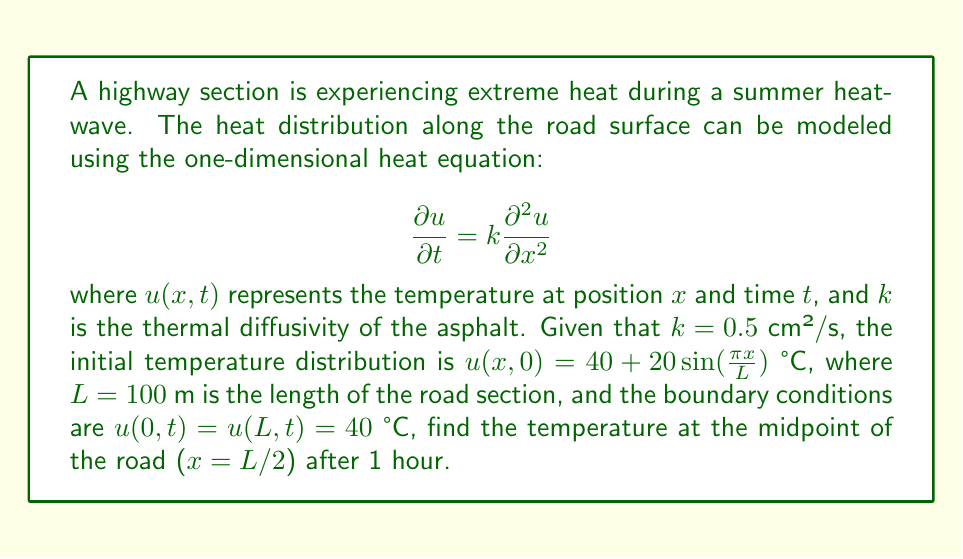Can you answer this question? To solve this problem, we'll use the method of separation of variables:

1) Assume a solution of the form $u(x,t) = X(x)T(t)$.

2) Substituting into the heat equation:
   $$X(x)T'(t) = kX''(x)T(t)$$
   $$\frac{T'(t)}{kT(t)} = \frac{X''(x)}{X(x)} = -\lambda$$

3) This gives us two ODEs:
   $$T'(t) + k\lambda T(t) = 0$$
   $$X''(x) + \lambda X(x) = 0$$

4) The boundary conditions imply $X(0) = X(L) = 0$, which gives the eigenvalues:
   $$\lambda_n = (\frac{n\pi}{L})^2, n = 1,2,3,...$$

5) The general solution is:
   $$u(x,t) = \sum_{n=1}^{\infty} A_n \sin(\frac{n\pi x}{L}) e^{-k(\frac{n\pi}{L})^2t}$$

6) The initial condition gives:
   $$40 + 20\sin(\frac{\pi x}{L}) = \sum_{n=1}^{\infty} A_n \sin(\frac{n\pi x}{L})$$

7) This implies $A_1 = 20$ and $A_n = 0$ for $n > 1$.

8) Therefore, the solution is:
   $$u(x,t) = 40 + 20\sin(\frac{\pi x}{L}) e^{-k(\frac{\pi}{L})^2t}$$

9) At the midpoint ($x = L/2$) after 1 hour ($t = 3600$ s):
   $$u(L/2, 3600) = 40 + 20\sin(\frac{\pi}{2}) e^{-0.5(\frac{\pi}{100})^2 \cdot 3600}$$

10) Calculating:
    $$u(L/2, 3600) = 40 + 20 \cdot e^{-0.5(\frac{\pi}{100})^2 \cdot 3600} \approx 55.68°C$$
Answer: 55.68°C 